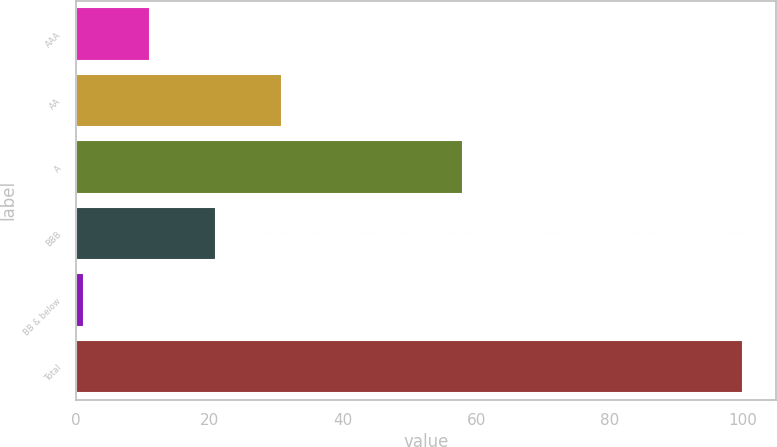Convert chart. <chart><loc_0><loc_0><loc_500><loc_500><bar_chart><fcel>AAA<fcel>AA<fcel>A<fcel>BBB<fcel>BB & below<fcel>Total<nl><fcel>11.08<fcel>30.84<fcel>58.1<fcel>20.96<fcel>1.2<fcel>100<nl></chart> 